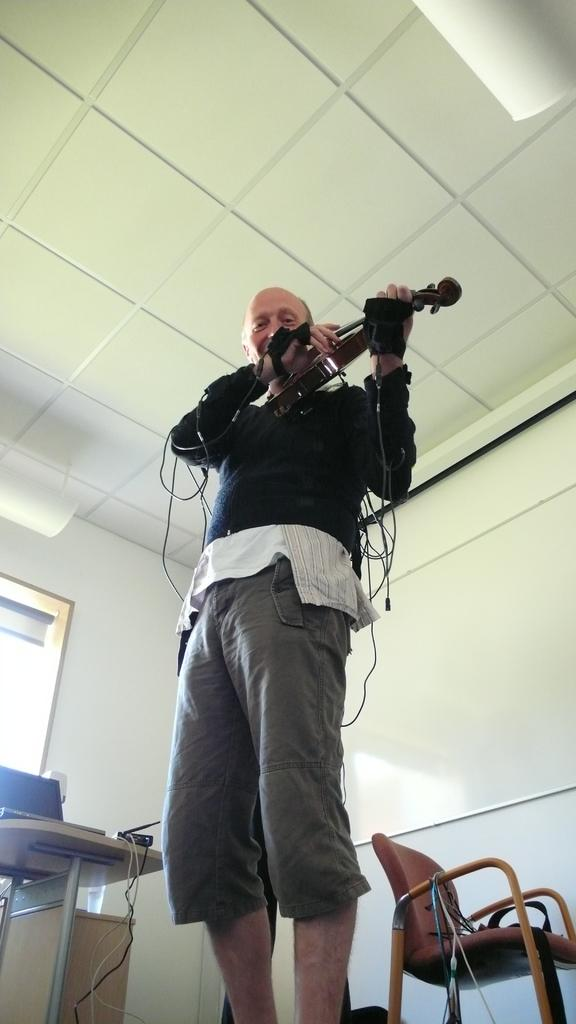What is the person in the image doing? The person is standing in the image. What is the person holding in their hands? The person is holding an object in their hands. What can be seen in the background of the image? There is a roof, a door, a table, and a chair visible in the background of the image. What color is the paint on the shoe in the image? There is no shoe or paint present in the image. How many feet can be seen in the image? There is no foot visible in the image; only a person standing and holding an object is shown. 